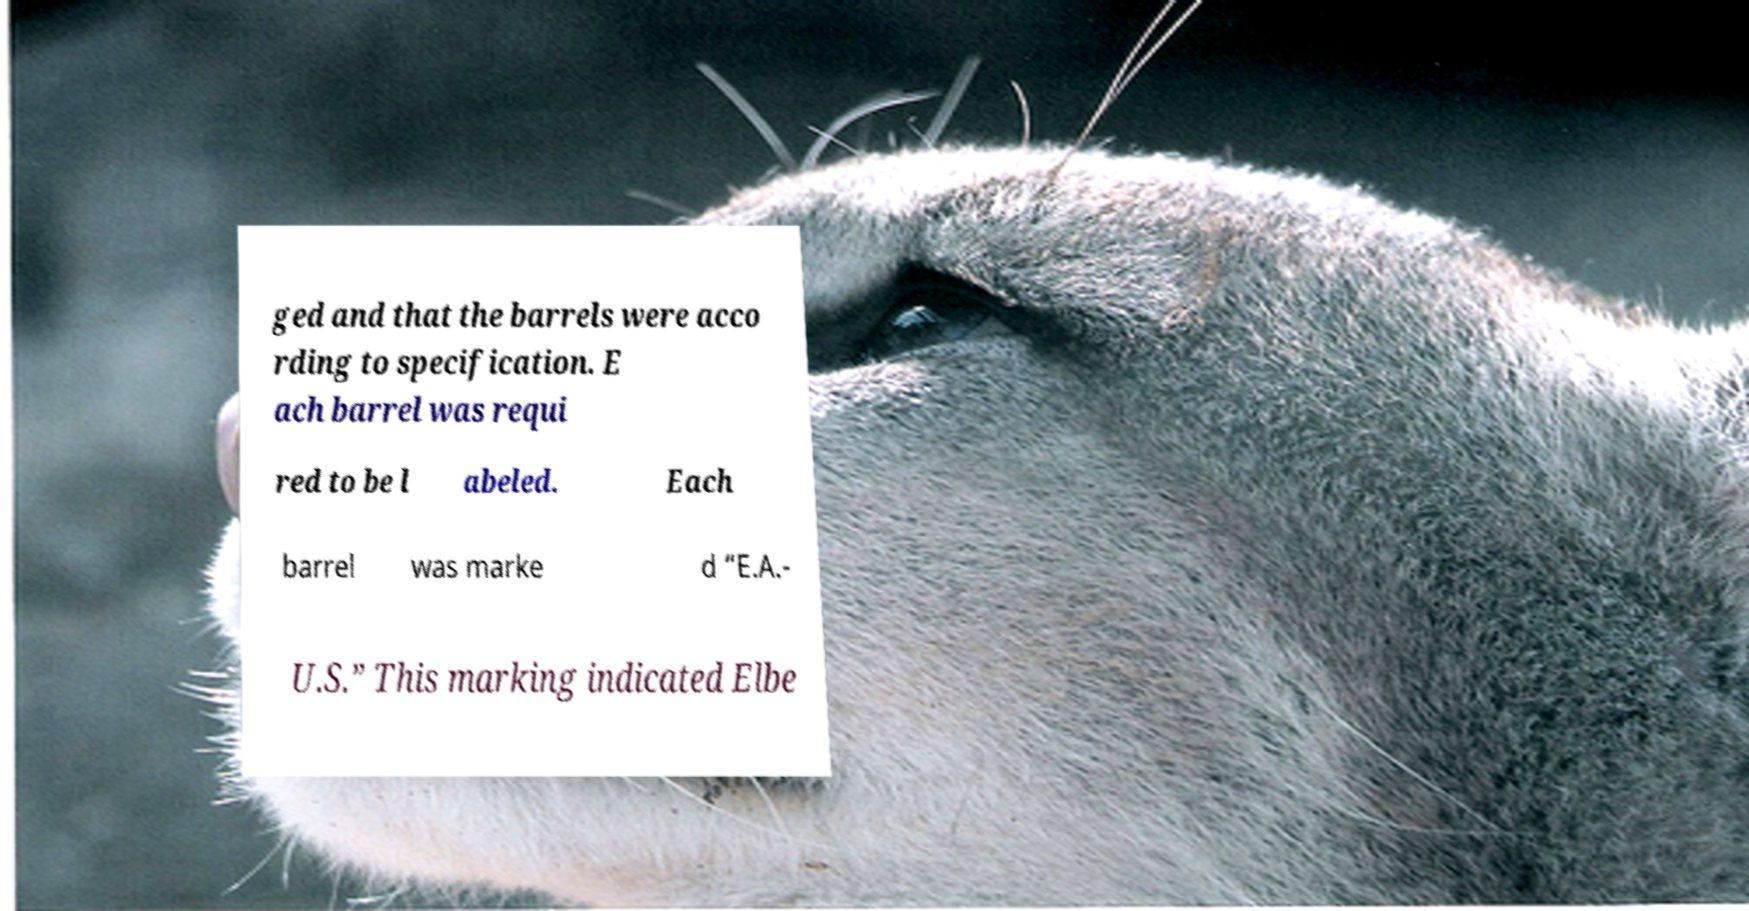Could you extract and type out the text from this image? ged and that the barrels were acco rding to specification. E ach barrel was requi red to be l abeled. Each barrel was marke d “E.A.- U.S.” This marking indicated Elbe 